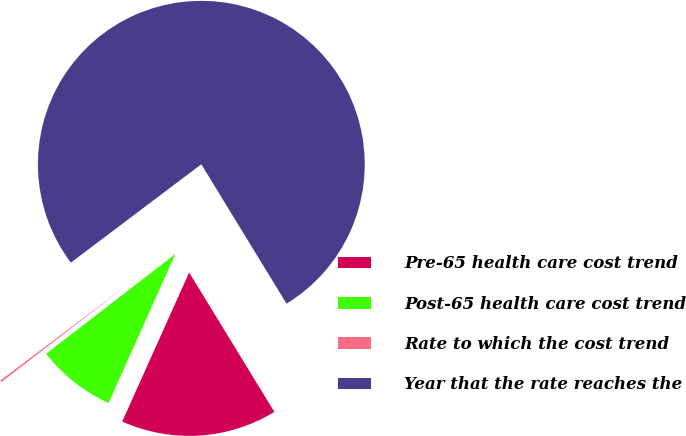Convert chart. <chart><loc_0><loc_0><loc_500><loc_500><pie_chart><fcel>Pre-65 health care cost trend<fcel>Post-65 health care cost trend<fcel>Rate to which the cost trend<fcel>Year that the rate reaches the<nl><fcel>15.45%<fcel>7.82%<fcel>0.18%<fcel>76.55%<nl></chart> 